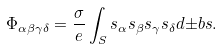<formula> <loc_0><loc_0><loc_500><loc_500>\Phi _ { \alpha \beta \gamma \delta } = \frac { \sigma } { e } \int _ { S } s _ { \alpha } s _ { \beta } s _ { \gamma } s _ { \delta } d { \pm b s } .</formula> 